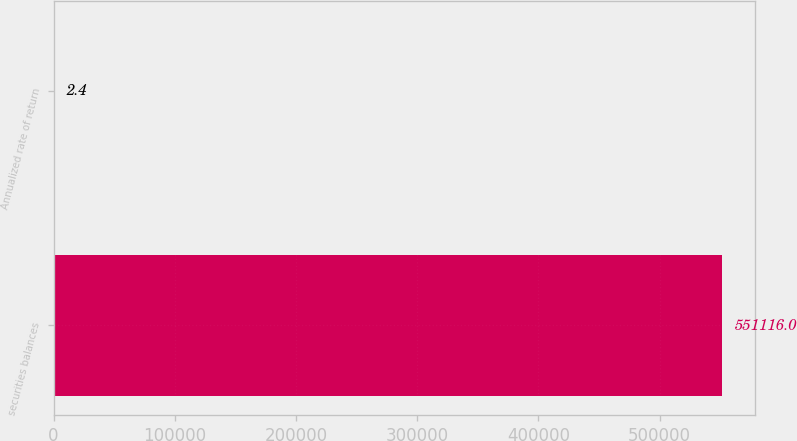Convert chart. <chart><loc_0><loc_0><loc_500><loc_500><bar_chart><fcel>securities balances<fcel>Annualized rate of return<nl><fcel>551116<fcel>2.4<nl></chart> 